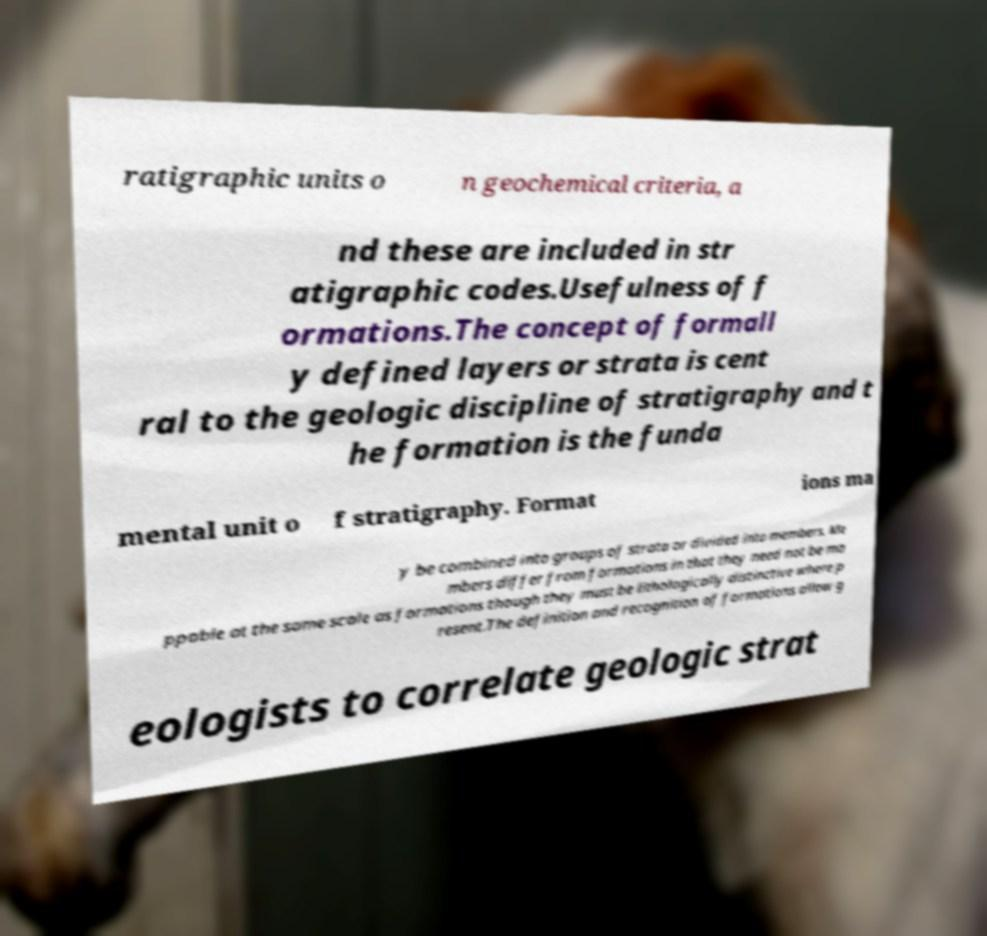I need the written content from this picture converted into text. Can you do that? ratigraphic units o n geochemical criteria, a nd these are included in str atigraphic codes.Usefulness of f ormations.The concept of formall y defined layers or strata is cent ral to the geologic discipline of stratigraphy and t he formation is the funda mental unit o f stratigraphy. Format ions ma y be combined into groups of strata or divided into members. Me mbers differ from formations in that they need not be ma ppable at the same scale as formations though they must be lithologically distinctive where p resent.The definition and recognition of formations allow g eologists to correlate geologic strat 